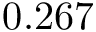Convert formula to latex. <formula><loc_0><loc_0><loc_500><loc_500>0 . 2 6 7</formula> 